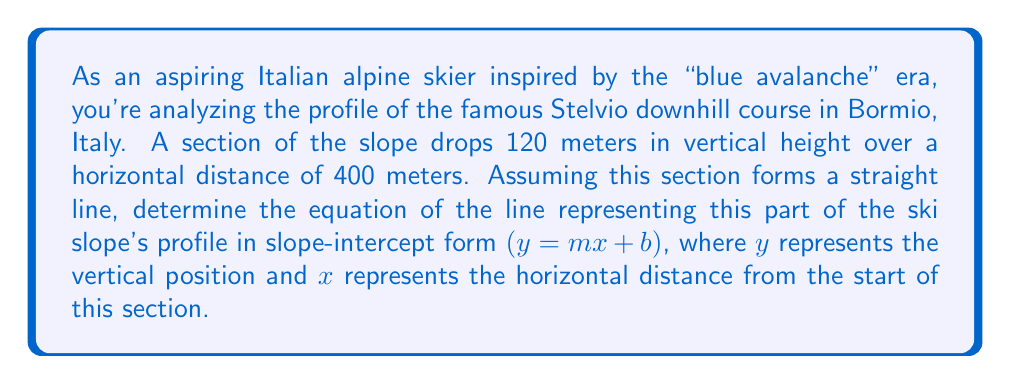Give your solution to this math problem. To find the equation of the line, we'll follow these steps:

1) First, let's calculate the slope $(m)$ of the line. The slope is the change in vertical position $(y)$ divided by the change in horizontal position $(x)$:

   $m = \frac{\Delta y}{\Delta x} = \frac{-120}{400} = -0.3$

   Note that we use -120 because the slope is descending (losing elevation).

2) Now that we have the slope, we need to find the y-intercept $(b)$. We can use the point-slope form of a line to do this:

   $y - y_1 = m(x - x_1)$

   Let's use the starting point of this section as our known point. If we consider this point to be $(0, 0)$, then:

   $y - 0 = -0.3(x - 0)$
   $y = -0.3x + b$

3) Since we've set our starting point as $(0, 0)$, the y-intercept $(b)$ is already 0.

4) Therefore, our final equation in slope-intercept form is:

   $y = -0.3x + 0$

   Or simply:

   $y = -0.3x$

This equation represents the profile of this section of the Stelvio course, where $x$ is the horizontal distance traveled and $y$ is the vertical position relative to the starting point of this section.
Answer: $y = -0.3x$ 